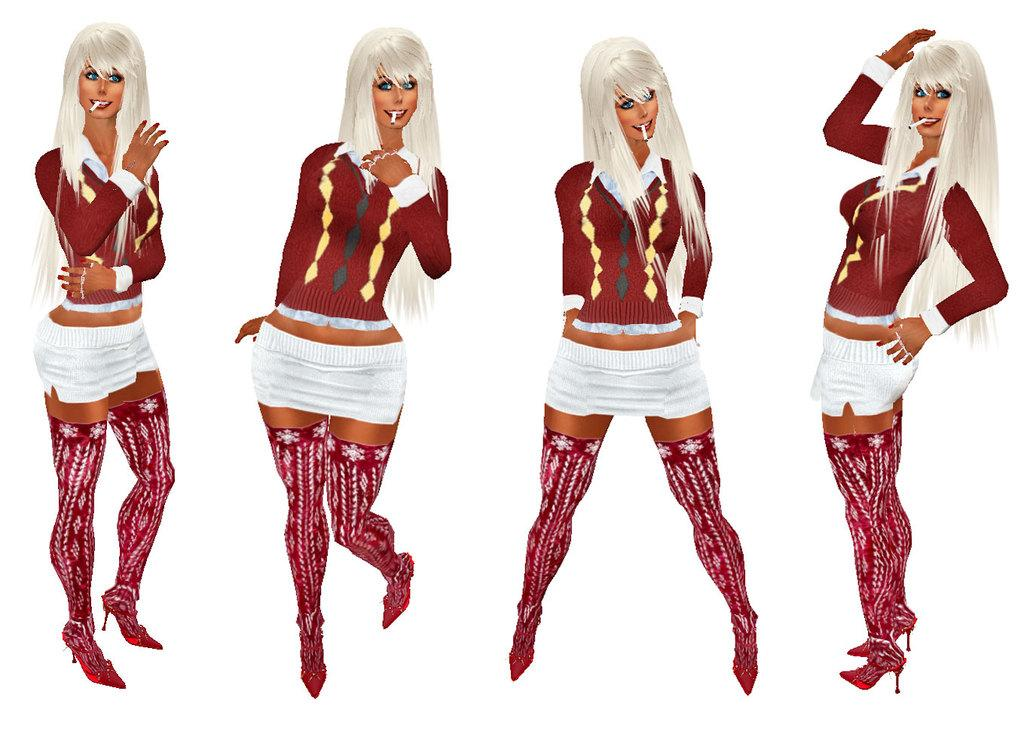What type of characters are depicted in the image? There are cartoon images of four women in the picture. What is the color of the background in the image? The background of the image is white. How many units of cake are visible in the image? There are no cakes present in the image; it features cartoon images of four women against a white background. 